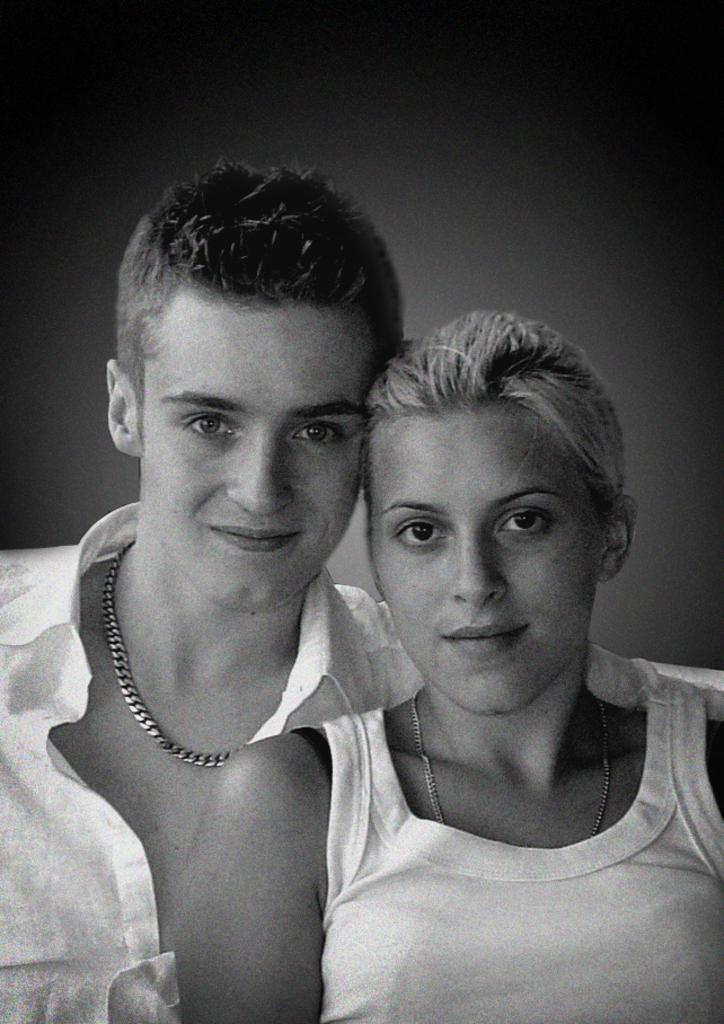Who are the people in the image? There is a lady and a man in the image. What can be said about the color scheme of the image? The image is in black and white mode. What type of throne is the lady sitting on in the image? There is no throne present in the image; it is a black and white image of a lady and a man. 